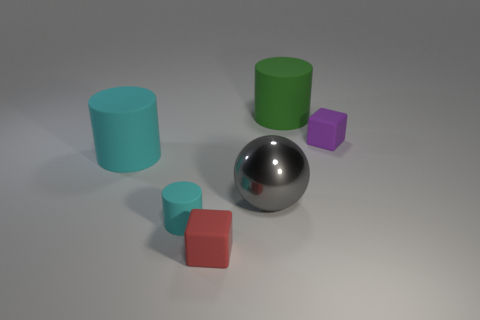Is there any other thing that has the same shape as the large gray metal object?
Ensure brevity in your answer.  No. Are there more objects on the right side of the big green matte cylinder than gray metallic balls left of the big metal ball?
Offer a very short reply. Yes. What number of large cyan matte things are right of the matte object on the right side of the green cylinder?
Offer a very short reply. 0. How many objects are either gray rubber spheres or small red matte things?
Make the answer very short. 1. Is the shape of the tiny cyan rubber thing the same as the big metal object?
Offer a terse response. No. What material is the green cylinder?
Provide a succinct answer. Rubber. What number of rubber things are both behind the tiny cyan object and on the left side of the red thing?
Your answer should be compact. 1. Is the size of the purple rubber block the same as the red cube?
Provide a succinct answer. Yes. There is a cylinder on the right side of the red matte cube; is its size the same as the large gray sphere?
Offer a very short reply. Yes. There is a thing that is on the right side of the big green cylinder; what is its color?
Keep it short and to the point. Purple. 